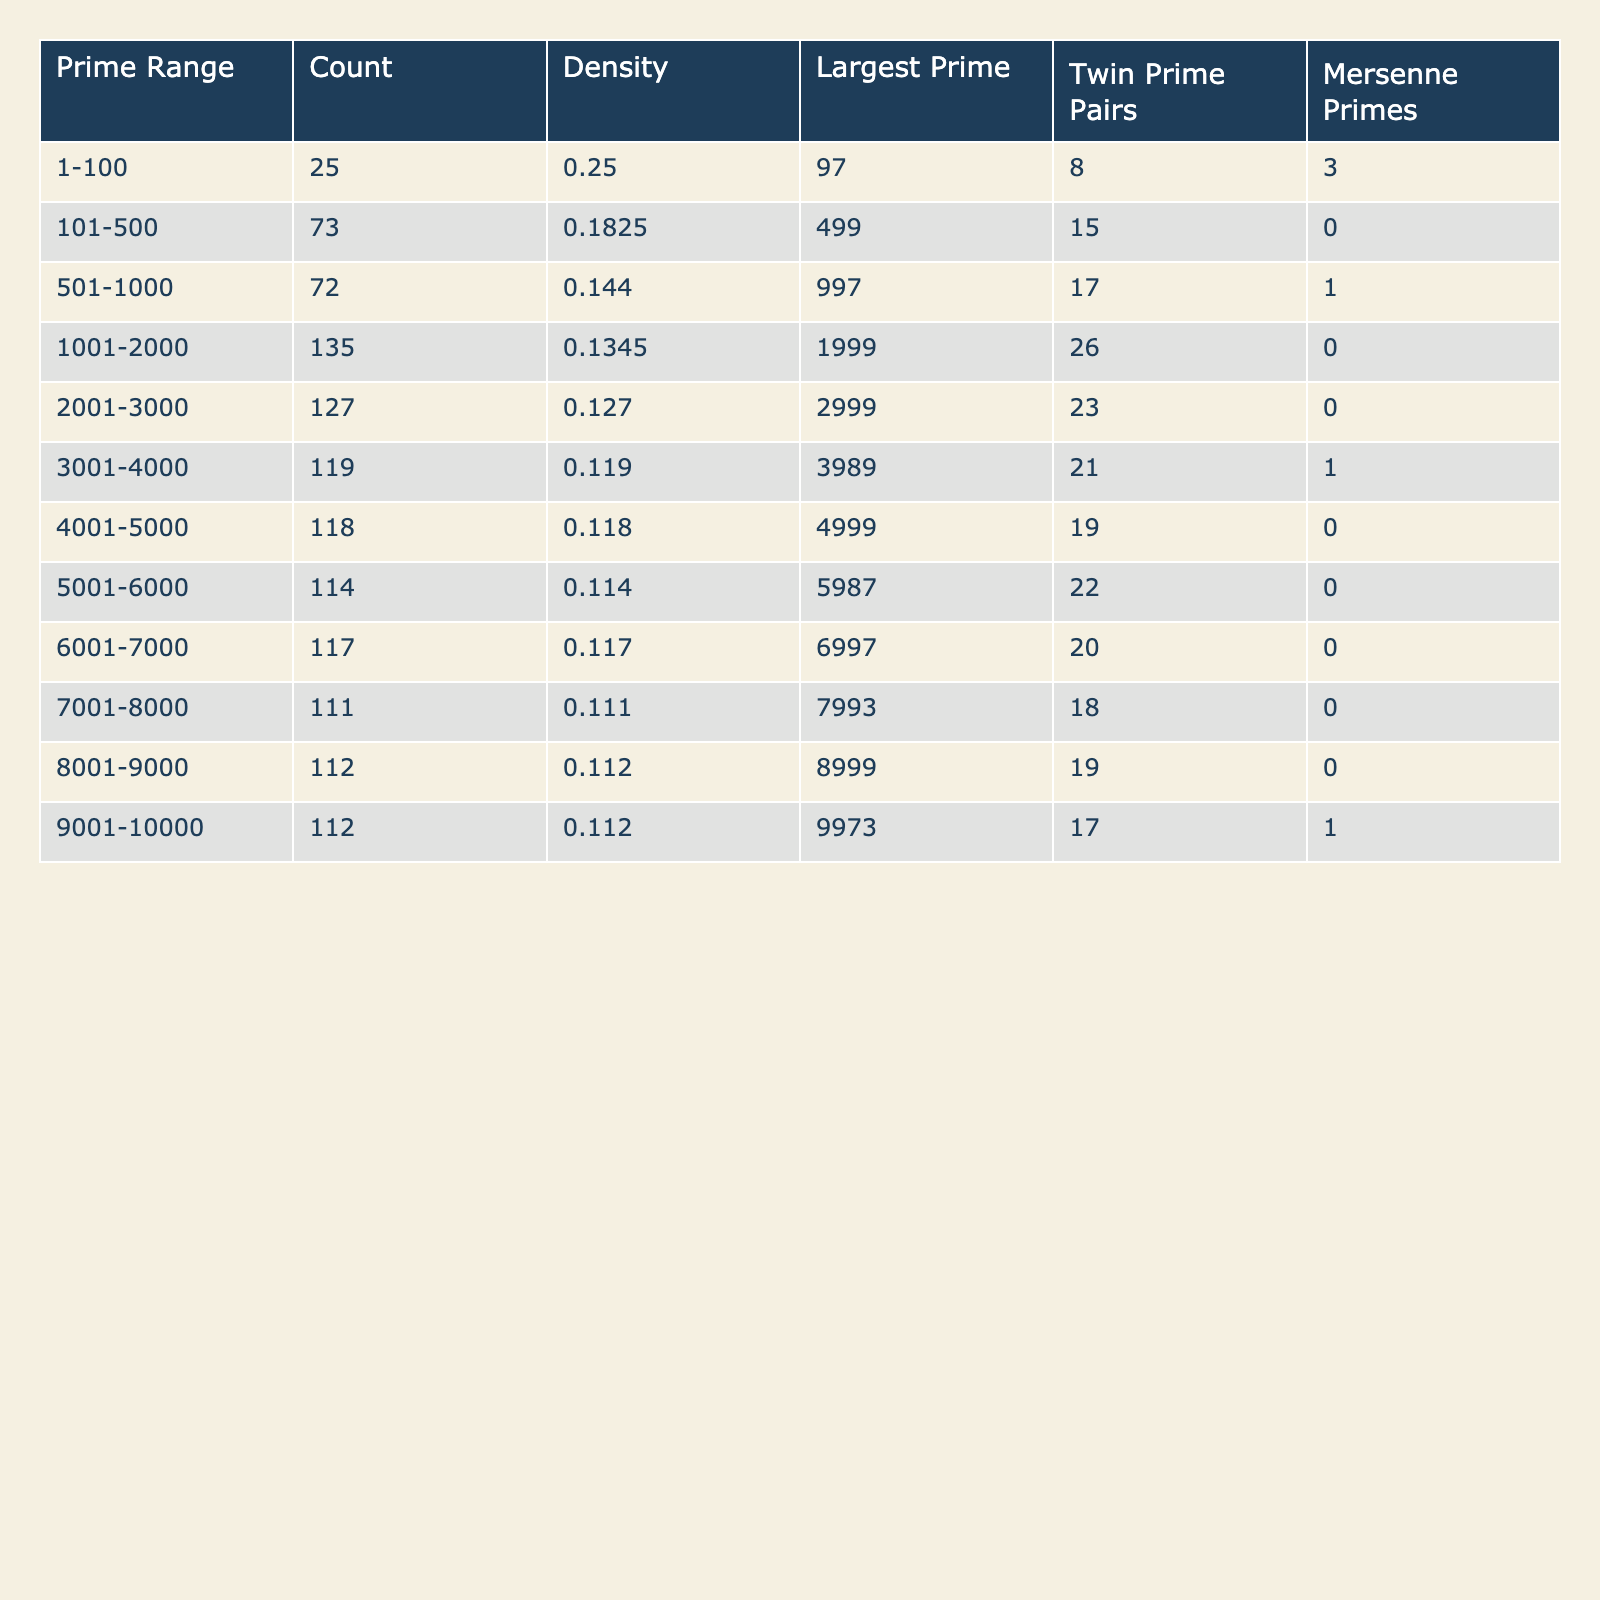What is the largest prime number in the range 1-100? Referring to the table, the largest prime number listed in the range of 1-100 is 97.
Answer: 97 How many twin prime pairs are there in the range 1001-2000? From the table, in the range of 1001-2000, there are 26 twin prime pairs indicated.
Answer: 26 What is the density of primes in the range 3001-4000? The table indicates that the density of primes in the range 3001-4000 is 0.119.
Answer: 0.119 What is the total number of prime numbers between 1 and 10000? To find this, we sum the counts from each range in the table: 25 + 73 + 72 + 135 + 127 + 119 + 118 + 114 + 117 + 111 + 112 + 112 = 1,576.
Answer: 1576 Is there a Mersenne prime in the range 101-500? According to the table, the range from 101-500 has 0 Mersenne primes listed. Therefore, the answer is no.
Answer: No Which range has the highest count of twin prime pairs, and what is that count? The highest count of twin prime pairs is in the range of 1-100, where there are 8 twin prime pairs recorded.
Answer: Range: 1-100, Count: 8 What is the average density of primes across all ranges listed in the table? First, we sum the densities: 0.25 + 0.1825 + 0.144 + 0.1345 + 0.127 + 0.119 + 0.118 + 0.114 + 0.117 + 0.111 + 0.112 + 0.112 = 1.538. Then, dividing by 12 ranges gives 1.538/12 ≈ 0.1282.
Answer: Approximately 0.128 What is the range with the lowest prime count and what is that count? Looking through the table, the range 7001-8000 has the lowest count of primes at 111.
Answer: 7001-8000, Count: 111 Are there more twin prime pairs in the range 2001-3000 than in the range 4001-5000? From the table, the range 2001-3000 has 23 twin prime pairs, while 4001-5000 has 19. Therefore, the former has more.
Answer: Yes What is the difference in count of primes between the ranges 5001-6000 and 4001-5000? The count of primes in the range 5001-6000 is 114, and for the range 4001-5000, it is 118. The difference is 114 - 118 = -4.
Answer: -4 